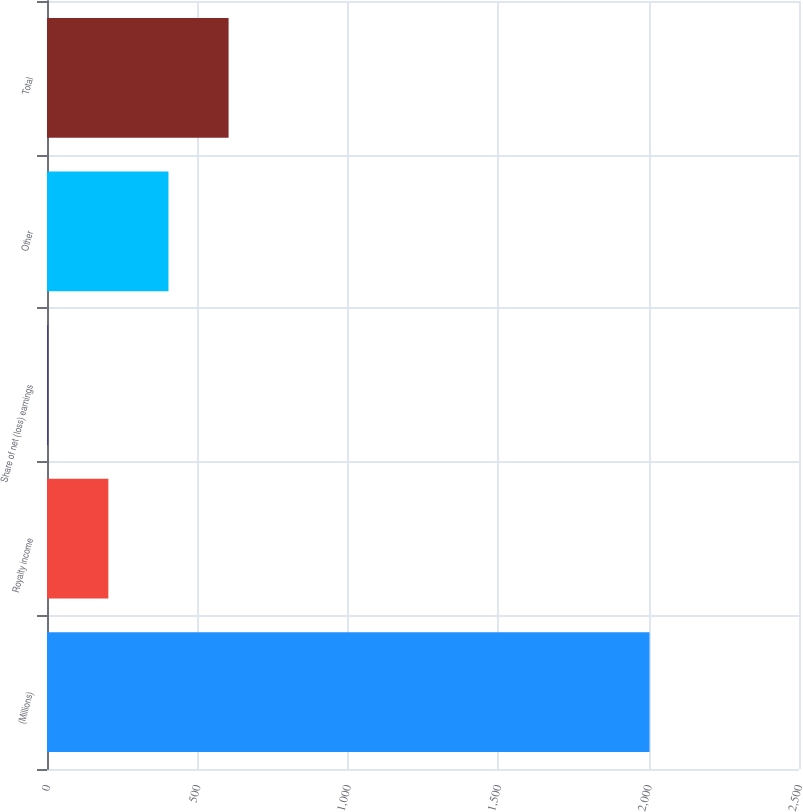Convert chart. <chart><loc_0><loc_0><loc_500><loc_500><bar_chart><fcel>(Millions)<fcel>Royalty income<fcel>Share of net (loss) earnings<fcel>Other<fcel>Total<nl><fcel>2003<fcel>203.9<fcel>4<fcel>403.8<fcel>603.7<nl></chart> 